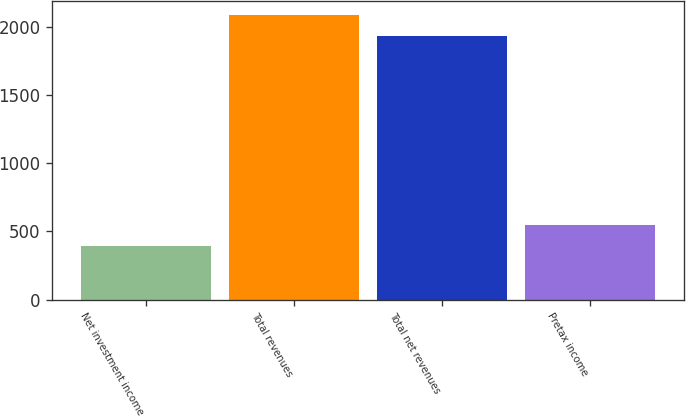Convert chart. <chart><loc_0><loc_0><loc_500><loc_500><bar_chart><fcel>Net investment income<fcel>Total revenues<fcel>Total net revenues<fcel>Pretax income<nl><fcel>395<fcel>2091.3<fcel>1937<fcel>549.3<nl></chart> 